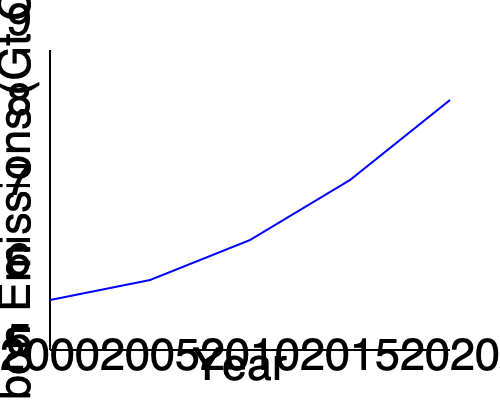The graph shows the trend of global carbon emissions from transportation over time. What can be inferred about the rate of change in emissions between 2000 and 2020? To determine the rate of change in emissions, we need to analyze the slope of the line:

1. Observe the overall trend: The line is moving upward from left to right, indicating an increase in emissions over time.

2. Compare the slope at different intervals:
   - 2000-2005: Slight increase
   - 2005-2010: Steeper increase
   - 2010-2015: Even steeper increase
   - 2015-2020: Steepest increase

3. Analyze the change in steepness:
   The line becomes progressively steeper as time goes on, which means the rate of increase is getting faster.

4. Interpret the meaning:
   A steeper slope indicates a faster rate of change. As the line gets steeper over time, it shows that the rate of increase in carbon emissions is accelerating.

5. Conclusion:
   The rate of change in emissions is not constant but is increasing over time, showing an accelerating trend in carbon emissions from transportation between 2000 and 2020.
Answer: Accelerating increase 